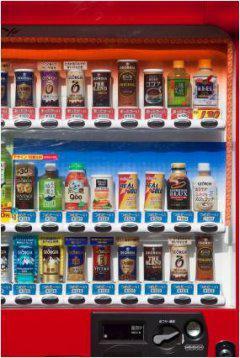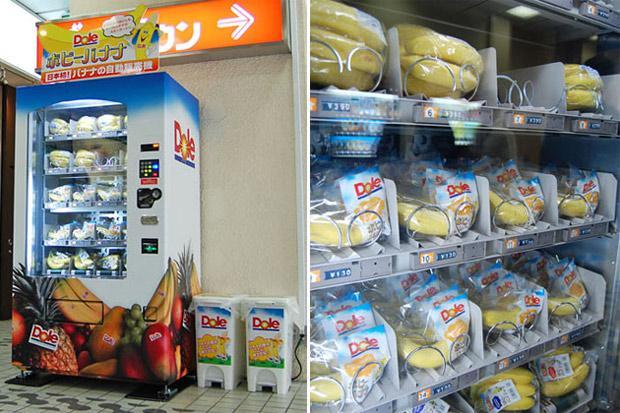The first image is the image on the left, the second image is the image on the right. For the images displayed, is the sentence "The image on the left features more than one vending machine." factually correct? Answer yes or no. No. The first image is the image on the left, the second image is the image on the right. Given the left and right images, does the statement "An image shows the front of one vending machine, which is red and displays three rows of items." hold true? Answer yes or no. Yes. 